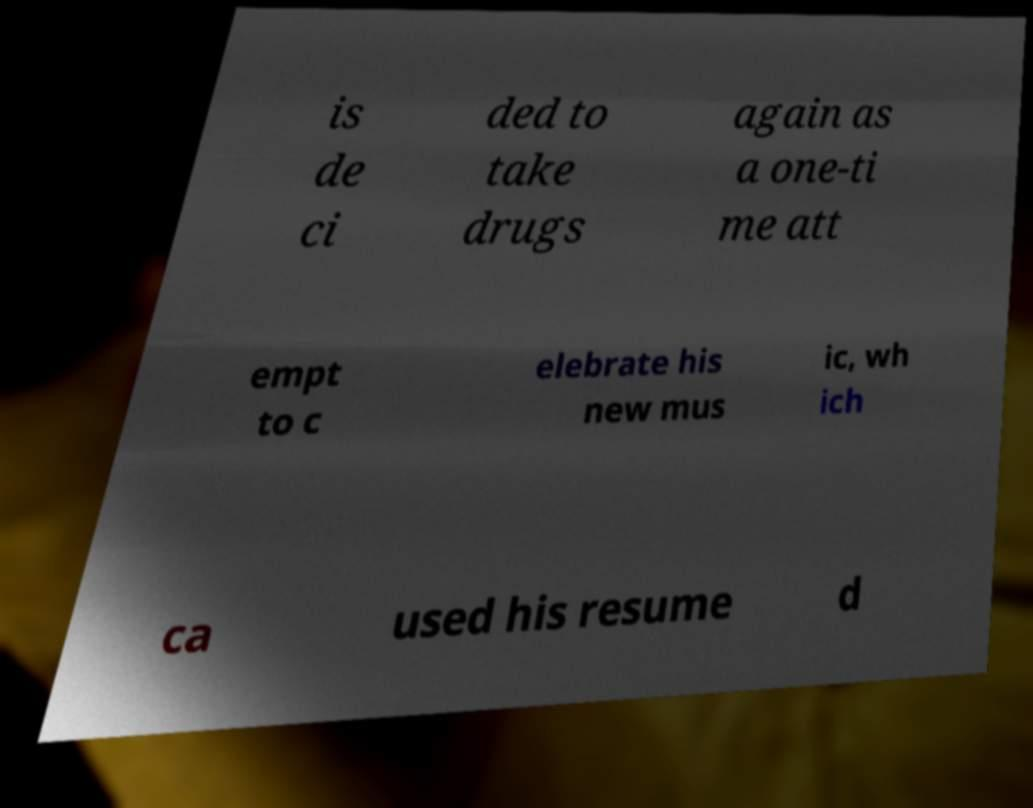Can you accurately transcribe the text from the provided image for me? is de ci ded to take drugs again as a one-ti me att empt to c elebrate his new mus ic, wh ich ca used his resume d 